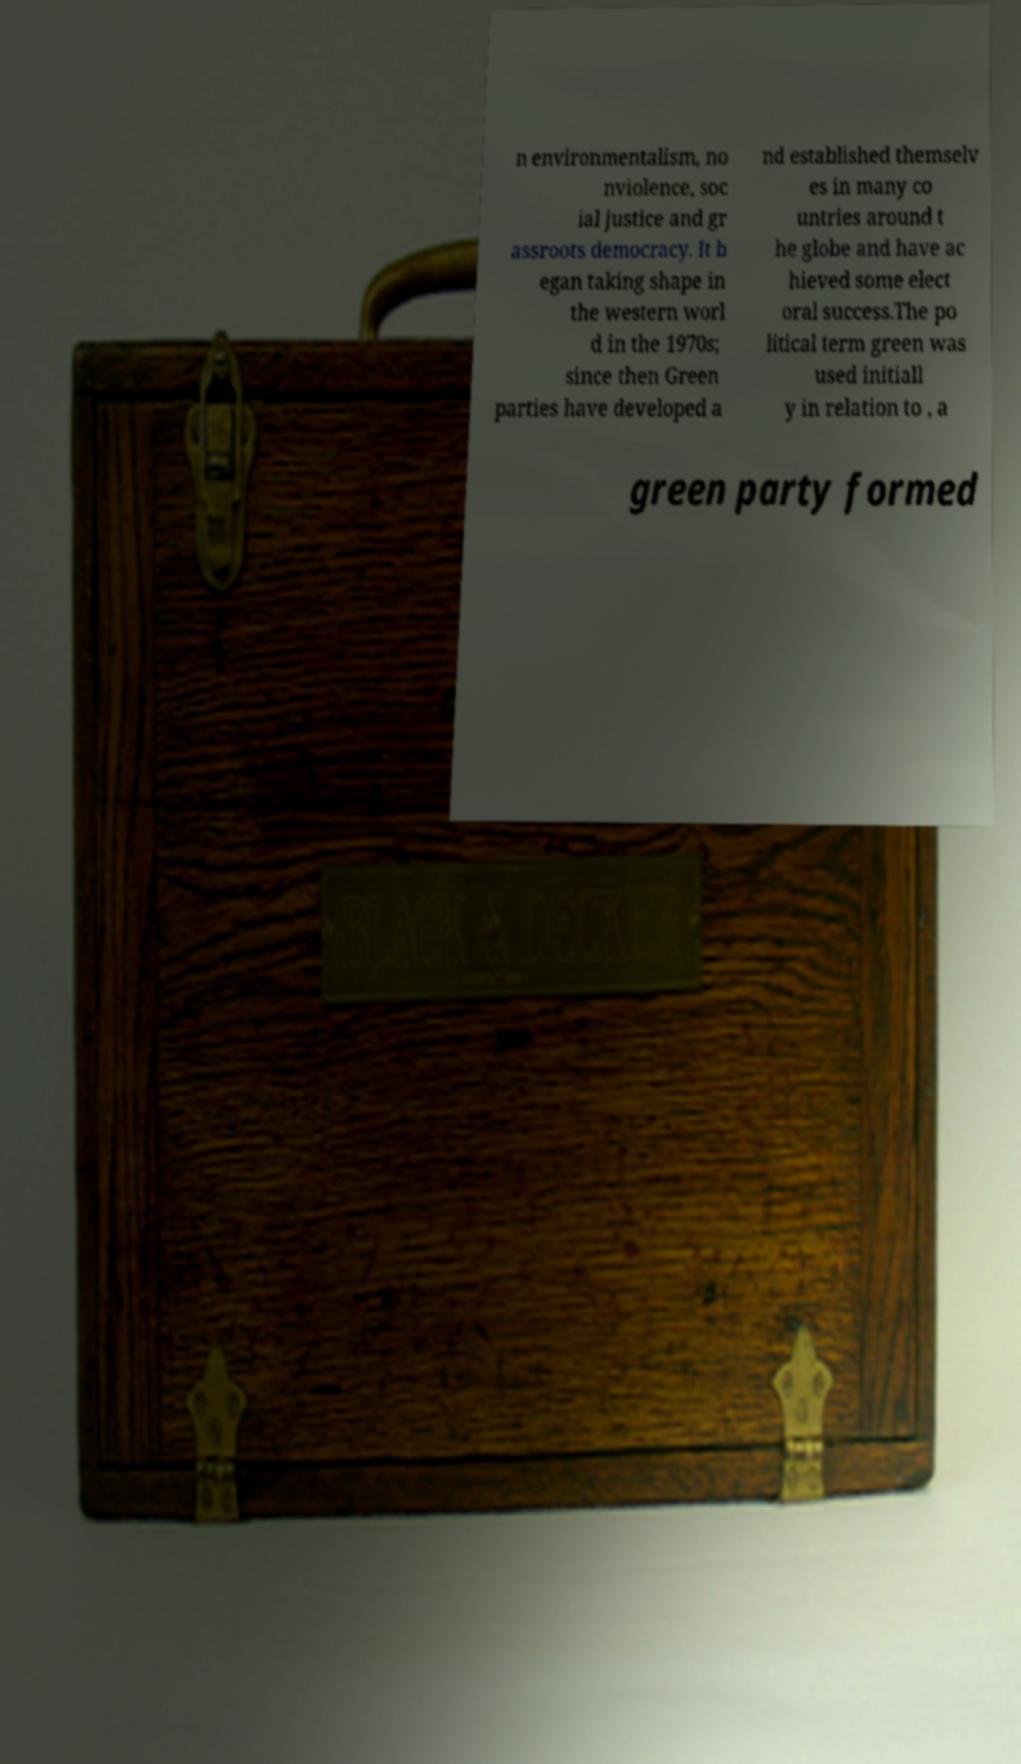There's text embedded in this image that I need extracted. Can you transcribe it verbatim? n environmentalism, no nviolence, soc ial justice and gr assroots democracy. It b egan taking shape in the western worl d in the 1970s; since then Green parties have developed a nd established themselv es in many co untries around t he globe and have ac hieved some elect oral success.The po litical term green was used initiall y in relation to , a green party formed 